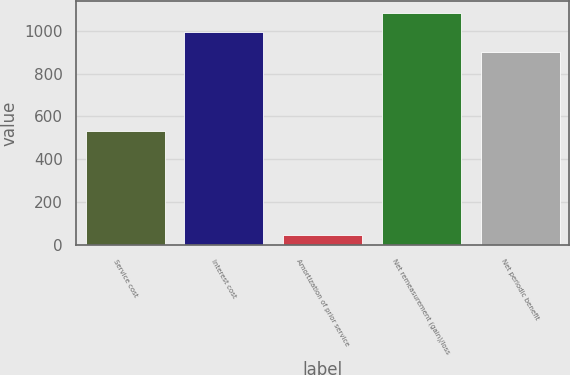<chart> <loc_0><loc_0><loc_500><loc_500><bar_chart><fcel>Service cost<fcel>Interest cost<fcel>Amortization of prior service<fcel>Net remeasurement (gain)/loss<fcel>Net periodic benefit<nl><fcel>532<fcel>992.7<fcel>47<fcel>1085.4<fcel>900<nl></chart> 